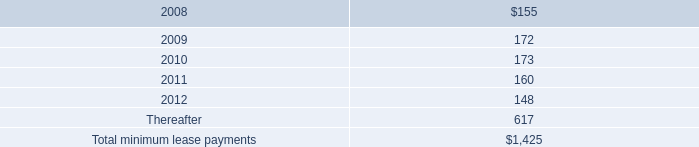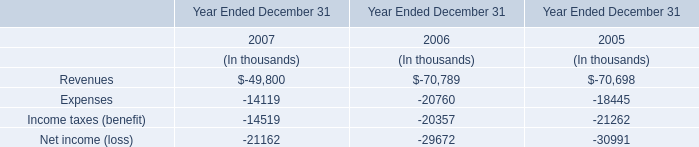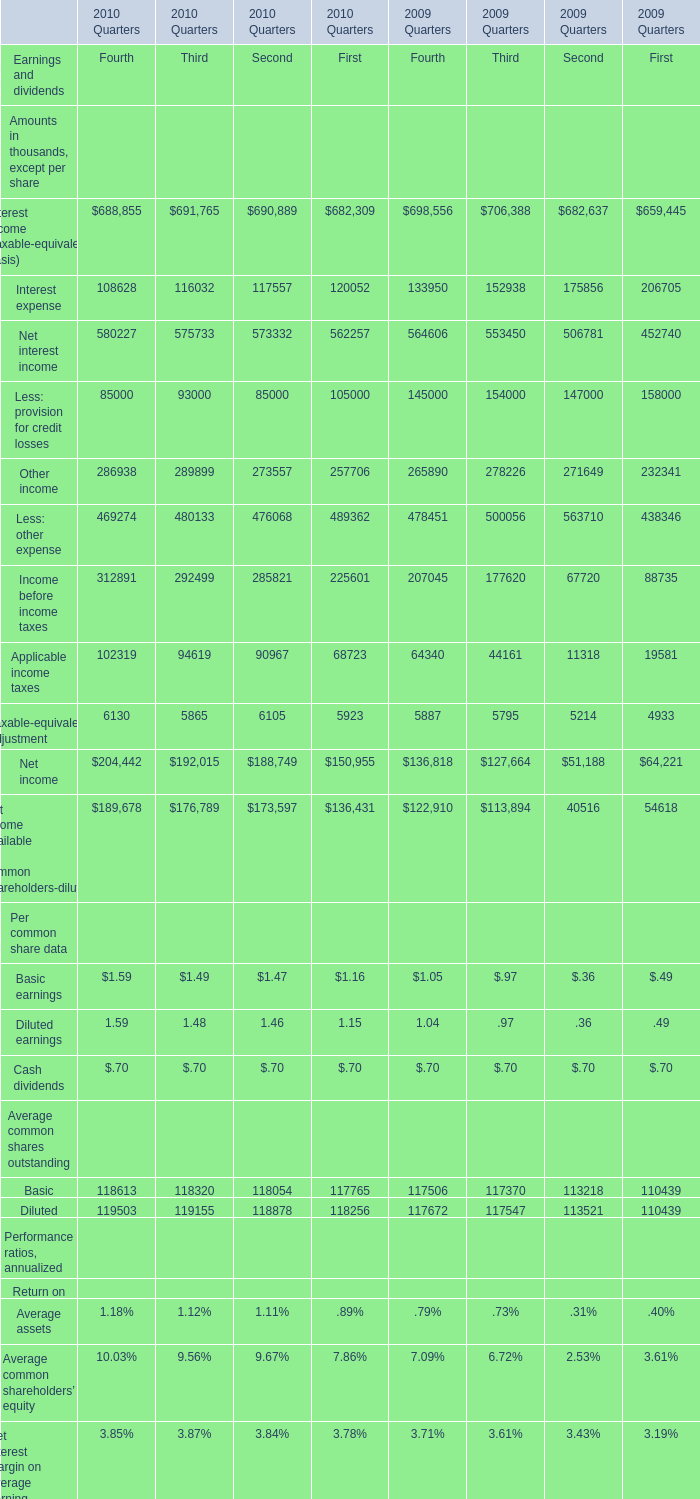as of september 29 , 2007 , what percent of the company 2019s total future minimum lease payments under noncancelable operating leases were related to leases for retail space? 
Computations: (1.1 / 1.4)
Answer: 0.78571. 